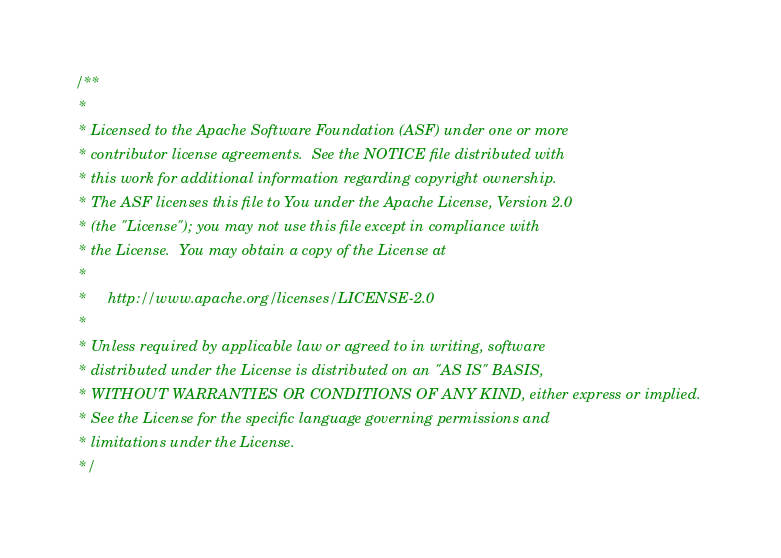<code> <loc_0><loc_0><loc_500><loc_500><_C++_>/**
 *
 * Licensed to the Apache Software Foundation (ASF) under one or more
 * contributor license agreements.  See the NOTICE file distributed with
 * this work for additional information regarding copyright ownership.
 * The ASF licenses this file to You under the Apache License, Version 2.0
 * (the "License"); you may not use this file except in compliance with
 * the License.  You may obtain a copy of the License at
 *
 *     http://www.apache.org/licenses/LICENSE-2.0
 *
 * Unless required by applicable law or agreed to in writing, software
 * distributed under the License is distributed on an "AS IS" BASIS,
 * WITHOUT WARRANTIES OR CONDITIONS OF ANY KIND, either express or implied.
 * See the License for the specific language governing permissions and
 * limitations under the License.
 */
</code> 